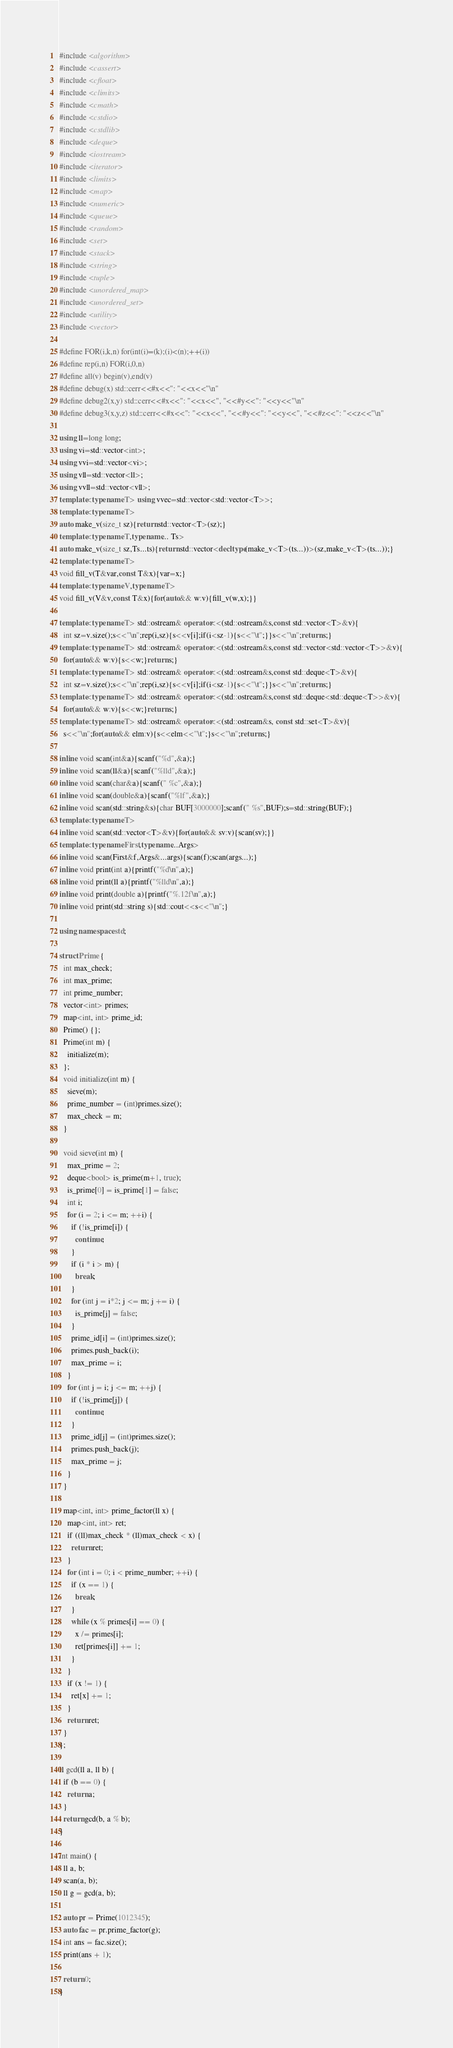<code> <loc_0><loc_0><loc_500><loc_500><_C++_>#include <algorithm>
#include <cassert>
#include <cfloat>
#include <climits>
#include <cmath>
#include <cstdio>
#include <cstdlib>
#include <deque>
#include <iostream>
#include <iterator>
#include <limits>
#include <map>
#include <numeric>
#include <queue>
#include <random>
#include <set>
#include <stack>
#include <string>
#include <tuple>
#include <unordered_map>
#include <unordered_set>
#include <utility>
#include <vector>

#define FOR(i,k,n) for(int(i)=(k);(i)<(n);++(i))
#define rep(i,n) FOR(i,0,n)
#define all(v) begin(v),end(v)
#define debug(x) std::cerr<<#x<<": "<<x<<"\n"
#define debug2(x,y) std::cerr<<#x<<": "<<x<<", "<<#y<<": "<<y<<"\n"
#define debug3(x,y,z) std::cerr<<#x<<": "<<x<<", "<<#y<<": "<<y<<", "<<#z<<": "<<z<<"\n"

using ll=long long;
using vi=std::vector<int>;
using vvi=std::vector<vi>;
using vll=std::vector<ll>;
using vvll=std::vector<vll>;
template<typename T> using vvec=std::vector<std::vector<T>>;
template<typename T>
auto make_v(size_t sz){return std::vector<T>(sz);}
template<typename T,typename... Ts>
auto make_v(size_t sz,Ts...ts){return std::vector<decltype(make_v<T>(ts...))>(sz,make_v<T>(ts...));}
template<typename T>
void fill_v(T&var,const T&x){var=x;}
template<typename V,typename T>
void fill_v(V&v,const T&x){for(auto&& w:v){fill_v(w,x);}}

template<typename T> std::ostream& operator<<(std::ostream&s,const std::vector<T>&v){
  int sz=v.size();s<<"\n";rep(i,sz){s<<v[i];if(i<sz-1){s<<"\t";}}s<<"\n";return s;}
template<typename T> std::ostream& operator<<(std::ostream&s,const std::vector<std::vector<T>>&v){
  for(auto&& w:v){s<<w;}return s;}
template<typename T> std::ostream& operator<<(std::ostream&s,const std::deque<T>&v){
  int sz=v.size();s<<"\n";rep(i,sz){s<<v[i];if(i<sz-1){s<<"\t";}}s<<"\n";return s;}
template<typename T> std::ostream& operator<<(std::ostream&s,const std::deque<std::deque<T>>&v){
  for(auto&& w:v){s<<w;}return s;}
template<typename T> std::ostream& operator<<(std::ostream&s, const std::set<T>&v){
  s<<"\n";for(auto&& elm:v){s<<elm<<"\t";}s<<"\n";return s;}

inline void scan(int&a){scanf("%d",&a);}
inline void scan(ll&a){scanf("%lld",&a);}
inline void scan(char&a){scanf(" %c",&a);}
inline void scan(double&a){scanf("%lf",&a);}
inline void scan(std::string&s){char BUF[3000000];scanf(" %s",BUF);s=std::string(BUF);}
template<typename T>
inline void scan(std::vector<T>&v){for(auto&& sv:v){scan(sv);}}
template<typename First,typename...Args>
inline void scan(First&f,Args&...args){scan(f);scan(args...);}
inline void print(int a){printf("%d\n",a);}
inline void print(ll a){printf("%lld\n",a);}
inline void print(double a){printf("%.12f\n",a);}
inline void print(std::string s){std::cout<<s<<"\n";}

using namespace std;

struct Prime {
  int max_check;
  int max_prime;
  int prime_number;
  vector<int> primes;
  map<int, int> prime_id;
  Prime() {};
  Prime(int m) {
    initialize(m);
  };
  void initialize(int m) {
    sieve(m);
    prime_number = (int)primes.size();
    max_check = m;
  }

  void sieve(int m) {
    max_prime = 2;
    deque<bool> is_prime(m+1, true);
    is_prime[0] = is_prime[1] = false;
    int i;
    for (i = 2; i <= m; ++i) {
      if (!is_prime[i]) {
        continue;
      }
      if (i * i > m) {
        break;
      }
      for (int j = i*2; j <= m; j += i) {
        is_prime[j] = false;
      }
      prime_id[i] = (int)primes.size();
      primes.push_back(i);
      max_prime = i;
    }
    for (int j = i; j <= m; ++j) {
      if (!is_prime[j]) {
        continue;
      }
      prime_id[j] = (int)primes.size();
      primes.push_back(j);
      max_prime = j;
    }
  }

  map<int, int> prime_factor(ll x) {
    map<int, int> ret;
    if ((ll)max_check * (ll)max_check < x) {
      return ret;
    }
    for (int i = 0; i < prime_number; ++i) {
      if (x == 1) {
        break;
      }
      while (x % primes[i] == 0) {
        x /= primes[i];
        ret[primes[i]] += 1;
      }
    }
    if (x != 1) {
      ret[x] += 1;
    }
    return ret;
  }
};

ll gcd(ll a, ll b) {
  if (b == 0) {
    return a;
  }
  return gcd(b, a % b);
}

int main() {
  ll a, b;
  scan(a, b);
  ll g = gcd(a, b);

  auto pr = Prime(1012345);
  auto fac = pr.prime_factor(g);
  int ans = fac.size();
  print(ans + 1);

  return 0;
}
</code> 